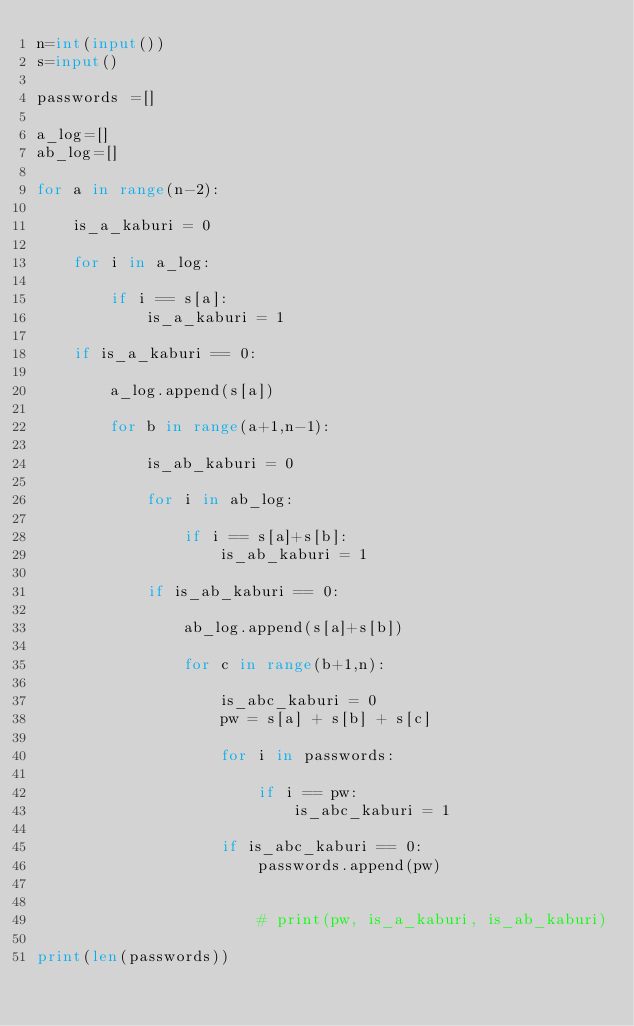Convert code to text. <code><loc_0><loc_0><loc_500><loc_500><_Python_>n=int(input())
s=input()

passwords =[]

a_log=[]
ab_log=[]

for a in range(n-2):
    
    is_a_kaburi = 0
    
    for i in a_log:
        
        if i == s[a]:
            is_a_kaburi = 1
            
    if is_a_kaburi == 0:
        
        a_log.append(s[a])
        
        for b in range(a+1,n-1):
            
            is_ab_kaburi = 0
            
            for i in ab_log:
                
                if i == s[a]+s[b]:
                    is_ab_kaburi = 1
                    
            if is_ab_kaburi == 0:
                
                ab_log.append(s[a]+s[b])
    
                for c in range(b+1,n):
                    
                    is_abc_kaburi = 0
                    pw = s[a] + s[b] + s[c] 
                    
                    for i in passwords:
                
                        if i == pw:
                            is_abc_kaburi = 1
                            
                    if is_abc_kaburi == 0:
                        passwords.append(pw)
    
                        
                        # print(pw, is_a_kaburi, is_ab_kaburi)

print(len(passwords))</code> 